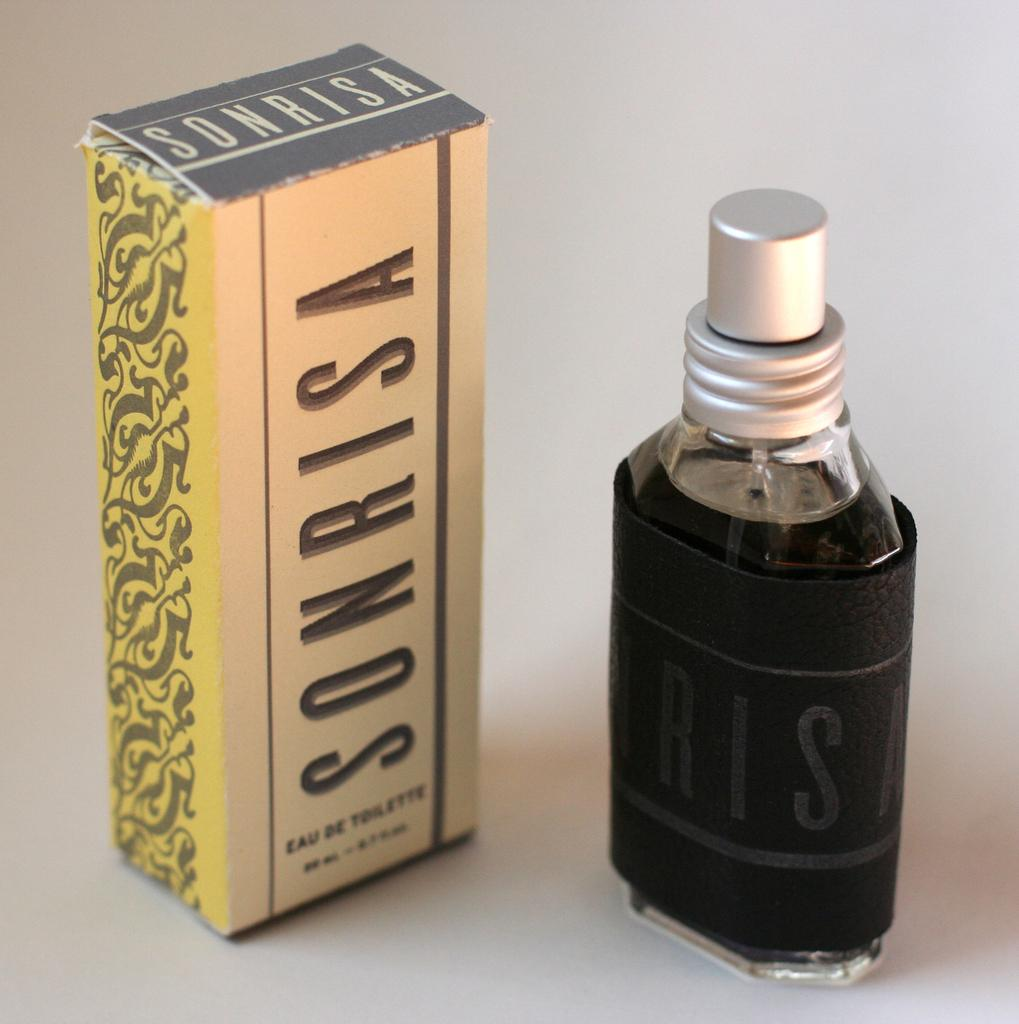<image>
Offer a succinct explanation of the picture presented. A bottle of Sonrisa is standing next to its box. 